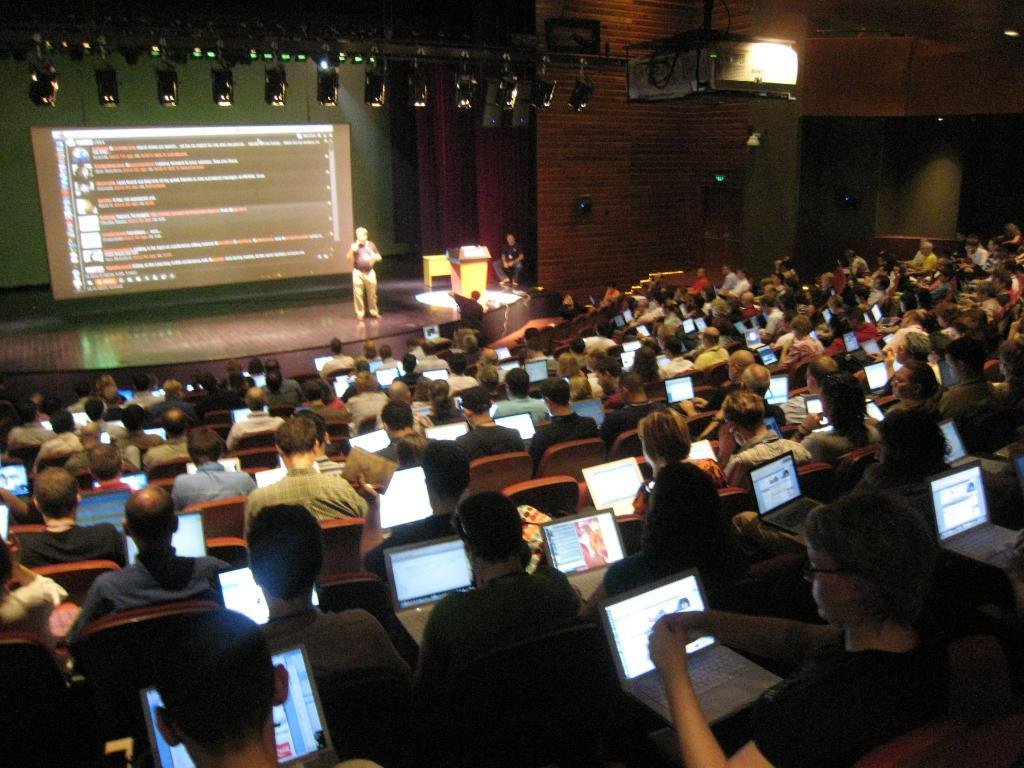What are the people in the room doing? The people in the room are sitting on chairs and holding laptops. What is the man standing on the stage doing? The man standing on the stage is likely presenting or speaking to the audience. What device is used to display the presentation? There is a projector in the room, which is likely used to display the presentation. What type of lighting is present in the room? There are lights on the top of the room, which provide illumination. Can you see any action figures on the bed in the image? There is no bed present in the image, and therefore no action figures can be seen. What type of plane is flying in the background of the image? There is no plane visible in the image; it is set in a room with a presentation and people using laptops. 